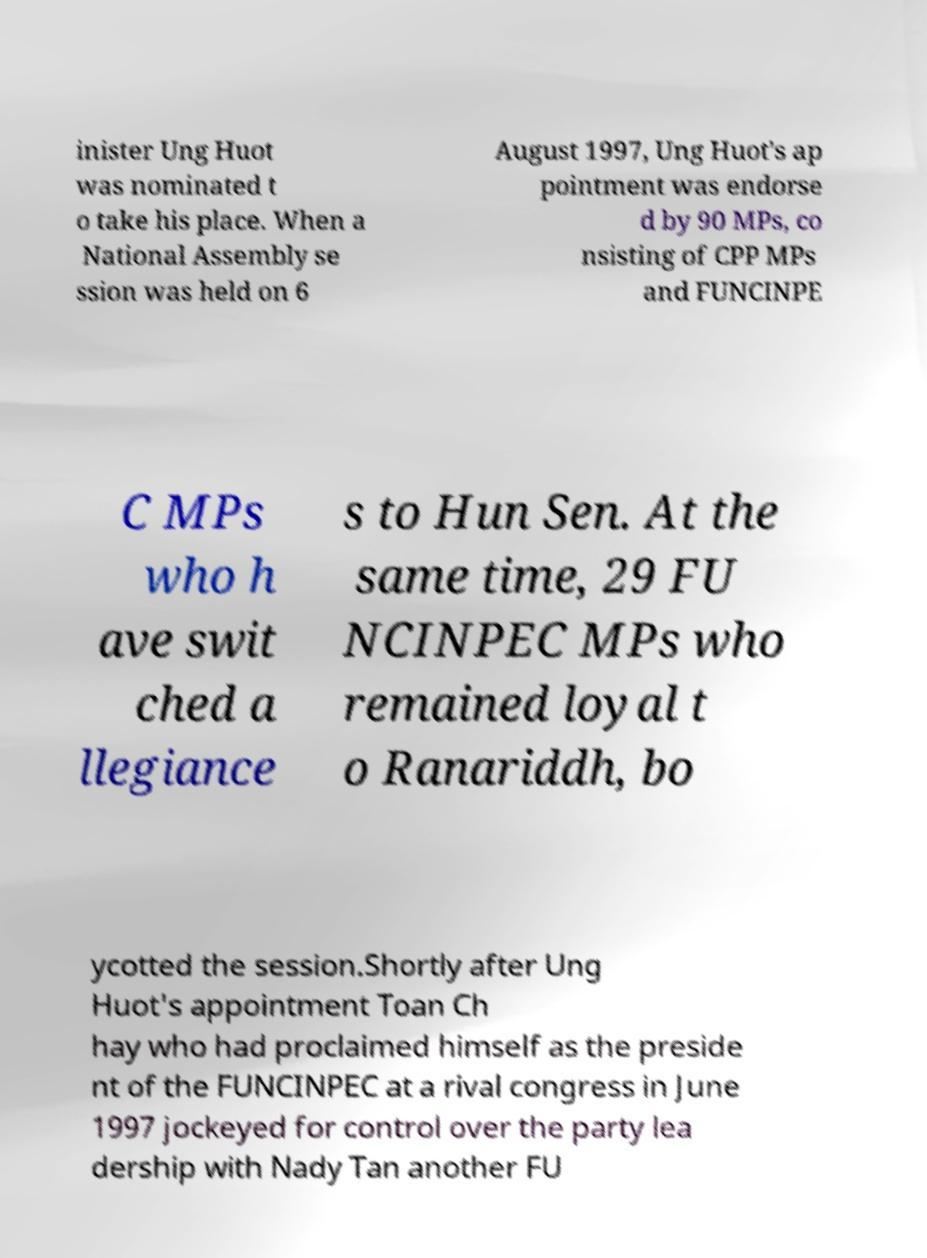Please identify and transcribe the text found in this image. inister Ung Huot was nominated t o take his place. When a National Assembly se ssion was held on 6 August 1997, Ung Huot's ap pointment was endorse d by 90 MPs, co nsisting of CPP MPs and FUNCINPE C MPs who h ave swit ched a llegiance s to Hun Sen. At the same time, 29 FU NCINPEC MPs who remained loyal t o Ranariddh, bo ycotted the session.Shortly after Ung Huot's appointment Toan Ch hay who had proclaimed himself as the preside nt of the FUNCINPEC at a rival congress in June 1997 jockeyed for control over the party lea dership with Nady Tan another FU 